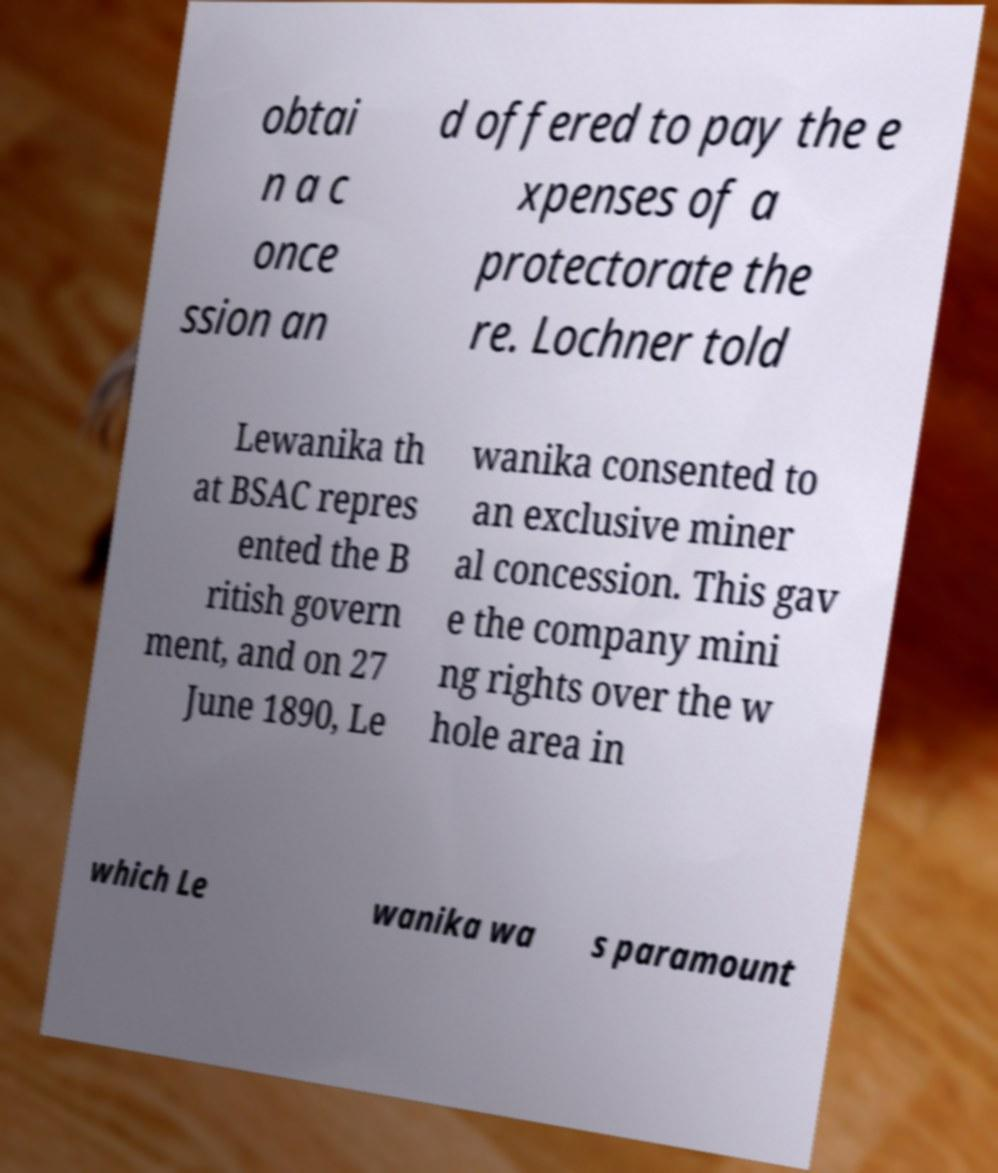Could you assist in decoding the text presented in this image and type it out clearly? obtai n a c once ssion an d offered to pay the e xpenses of a protectorate the re. Lochner told Lewanika th at BSAC repres ented the B ritish govern ment, and on 27 June 1890, Le wanika consented to an exclusive miner al concession. This gav e the company mini ng rights over the w hole area in which Le wanika wa s paramount 